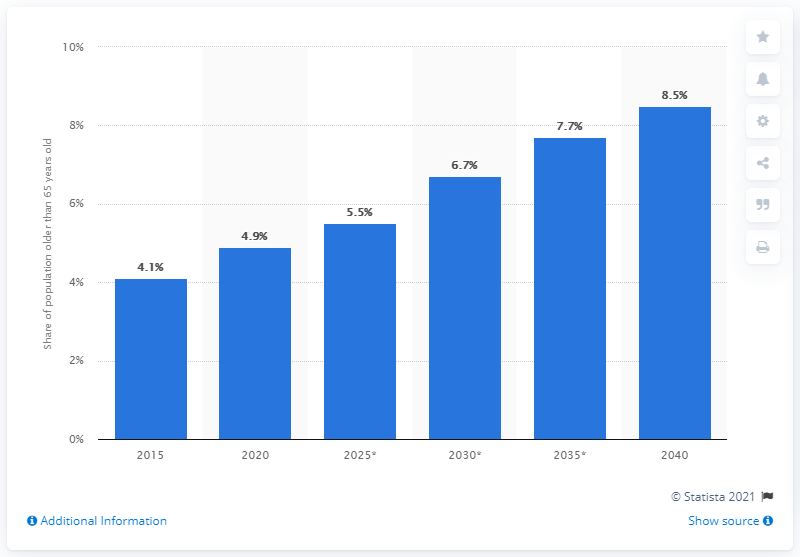Identify some key points in this picture. It was predicted that by the year 2040, 8.5 percent of the Cambodian population would be 65 years or older. In 2020, approximately 4.9% of the Cambodian population was over 65 years old. According to the given information, approximately 8.5% of Cambodia's population is older than 65 years old. 